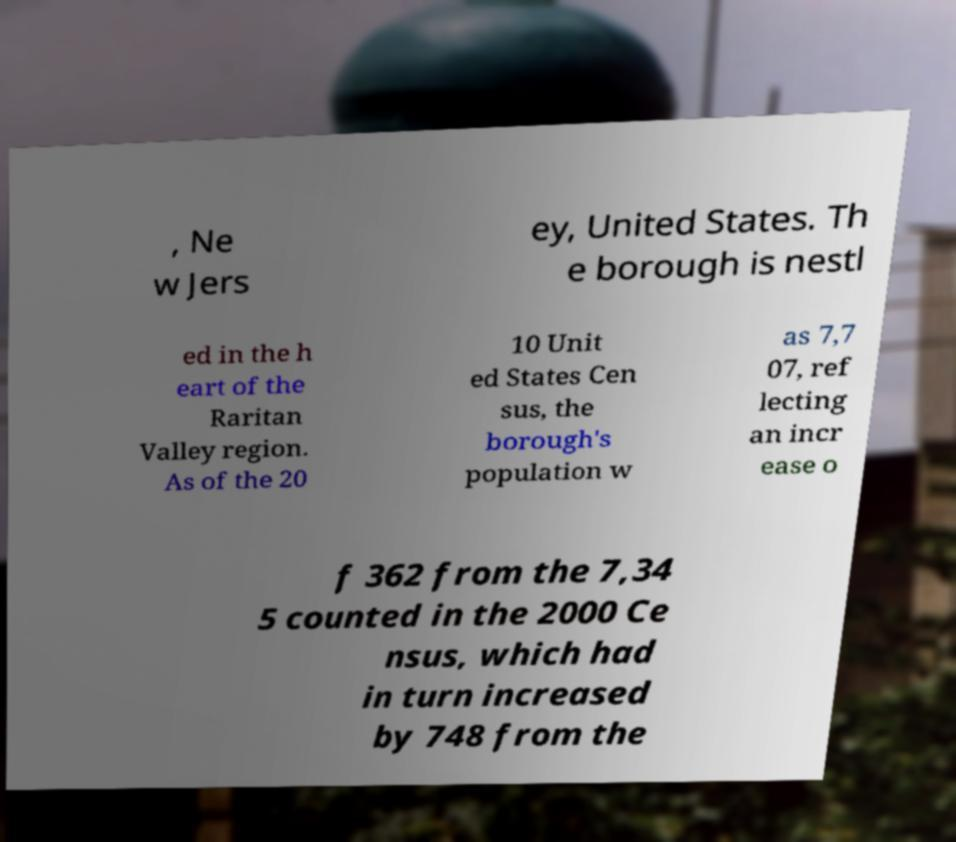Could you extract and type out the text from this image? , Ne w Jers ey, United States. Th e borough is nestl ed in the h eart of the Raritan Valley region. As of the 20 10 Unit ed States Cen sus, the borough's population w as 7,7 07, ref lecting an incr ease o f 362 from the 7,34 5 counted in the 2000 Ce nsus, which had in turn increased by 748 from the 